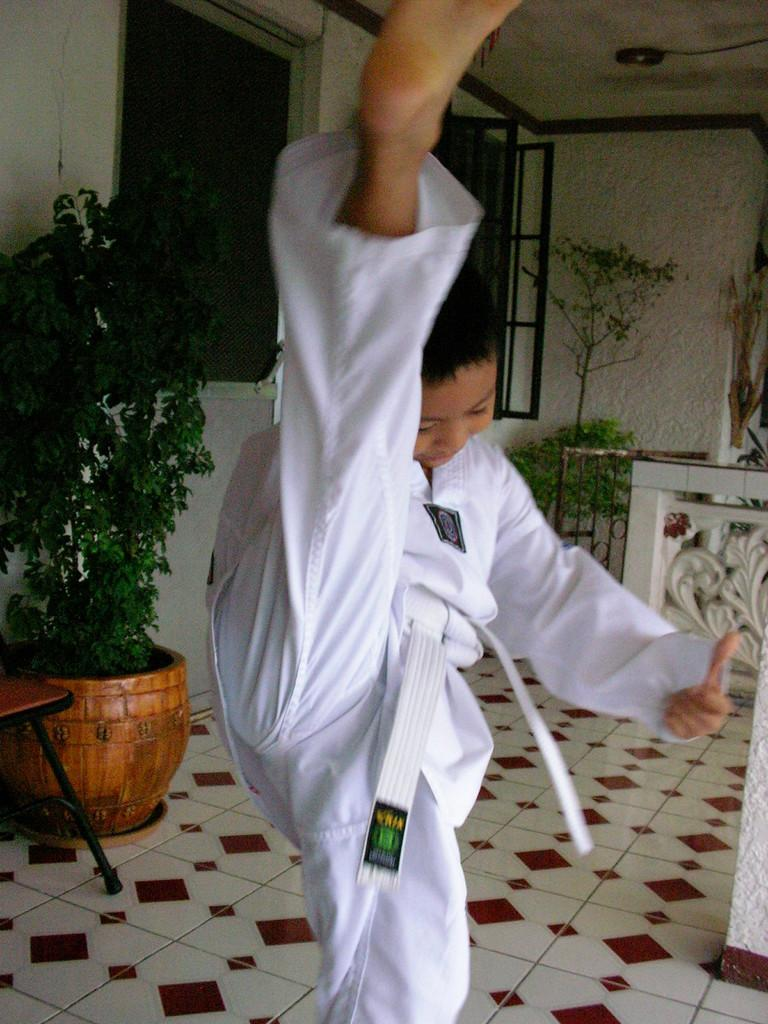What is the main subject of the image? There is a karate kid in the image. What is the karate kid doing in the image? The karate kid is stretching his leg upward. What can be seen in the background of the image? There is a plant pot in the background of the image. What is visible behind the plant pot? There are windows behind the plant pot. Where is the nest located in the image? There is no nest present in the image. How many knots are visible on the karate kid's belt in the image? The image does not show the karate kid's belt, so it is not possible to determine the number of knots. 